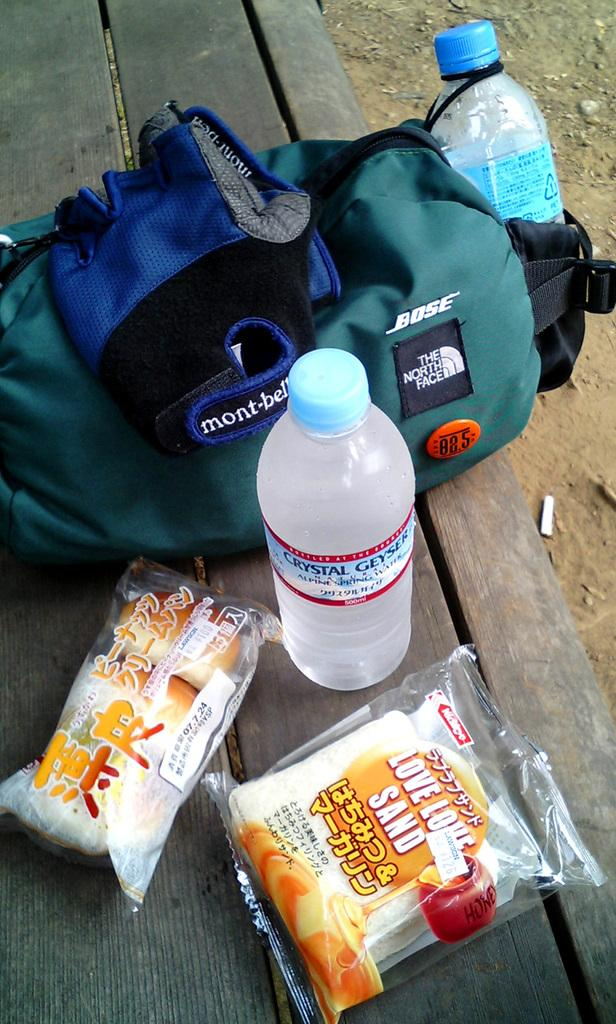How many bottles are visible in the image? There are two bottles in the image. What other items can be seen in the image besides the bottles? There is a bag, a glove, and two packets of food in the image. What type of haircut is the person in the image getting? There is no person getting a haircut in the image. How many days are in the week depicted in the image? There is no reference to a week or days in the image. 